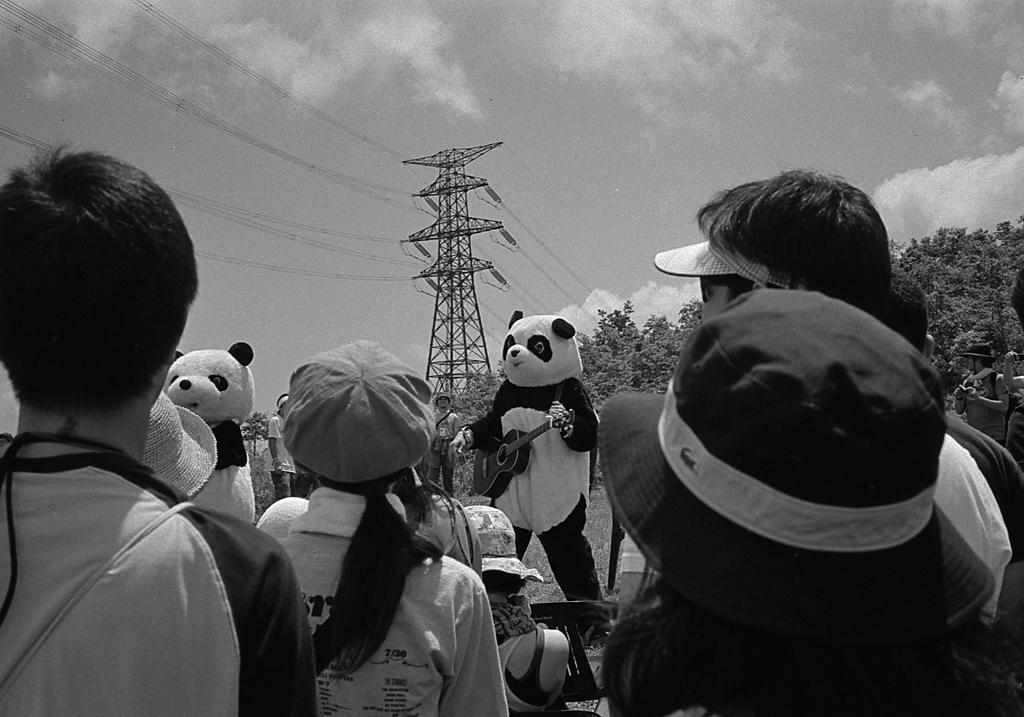In one or two sentences, can you explain what this image depicts? In this picture we can observe two members who were dressed up like a panda. One of them was holding a guitar their hands. We can observe some people standing, wearing caps and hats on their heads. In the background we can observe trees, tower and some wires. We can observe a sky with some clouds here. 